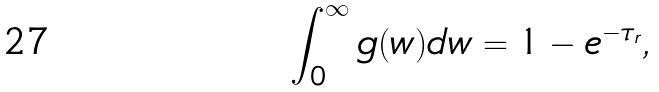<formula> <loc_0><loc_0><loc_500><loc_500>\int ^ { \infty } _ { 0 } g ( w ) d w = 1 - e ^ { - \tau _ { r } } ,</formula> 